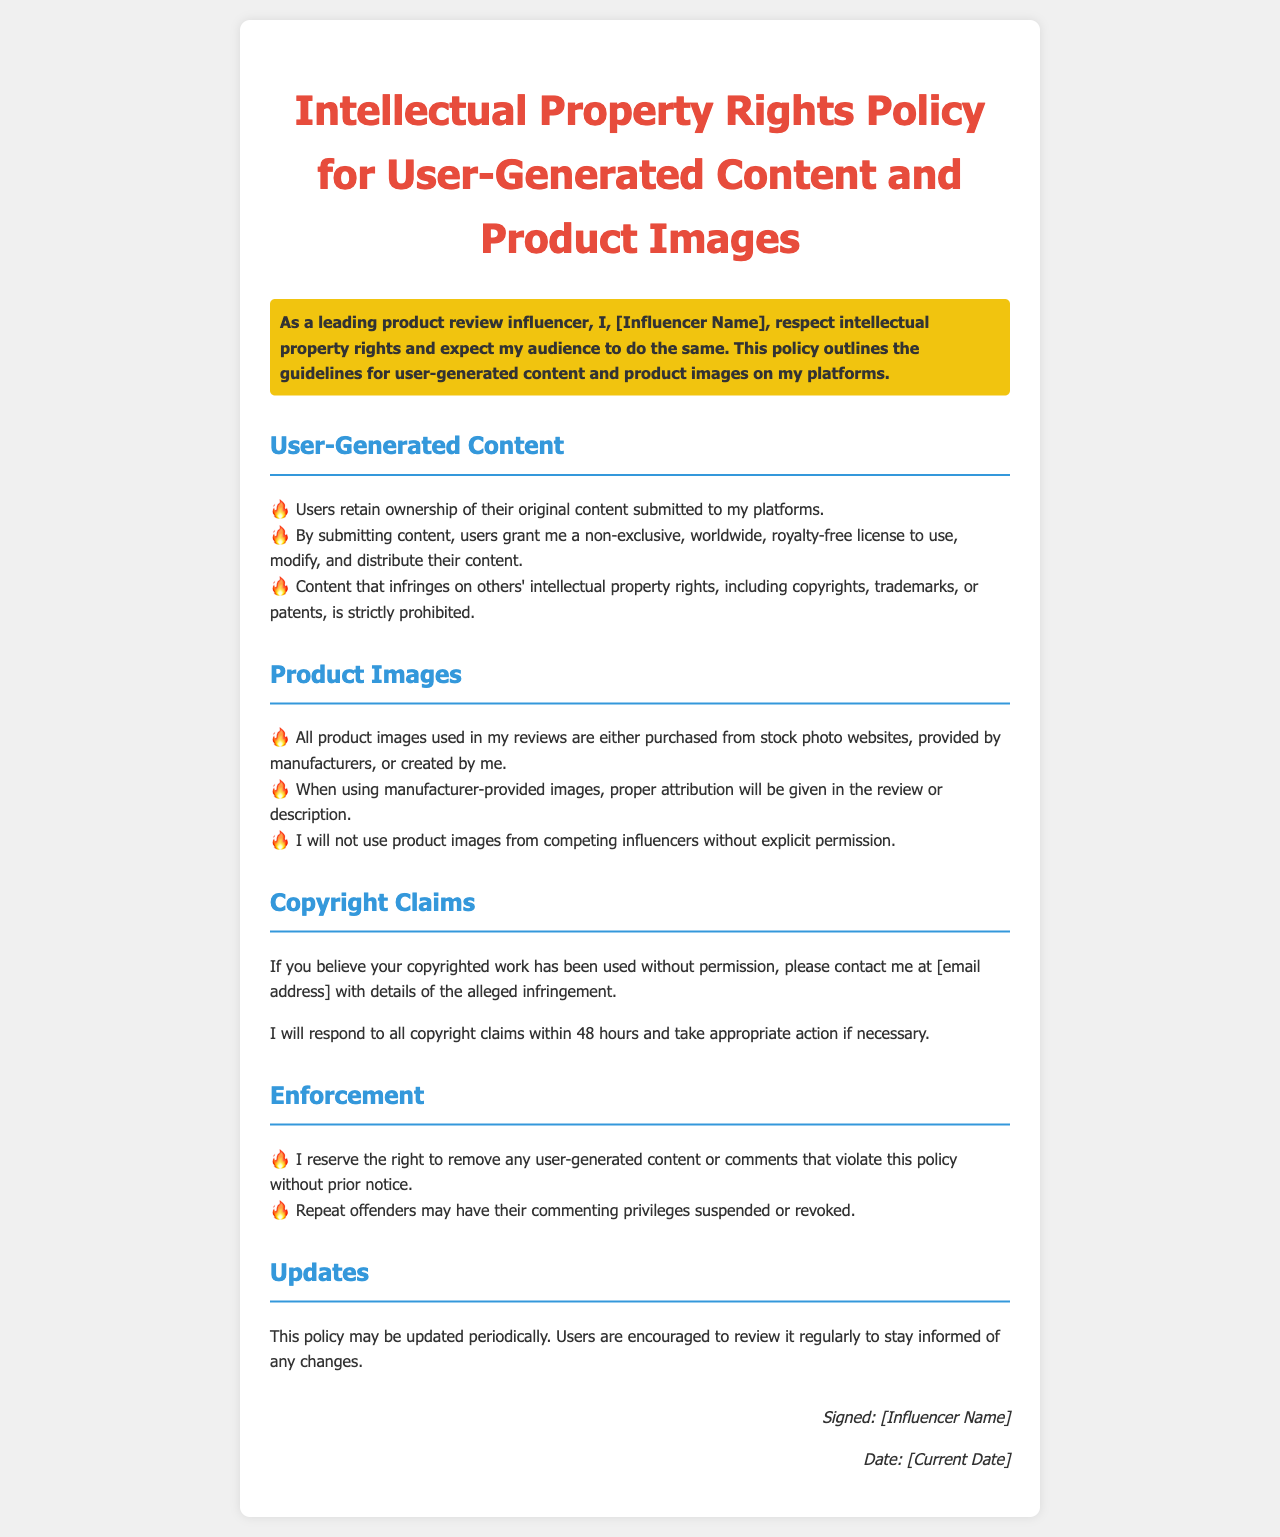What is the title of the document? The title is stated at the top of the document as "Intellectual Property Rights Policy for User-Generated Content and Product Images."
Answer: Intellectual Property Rights Policy for User-Generated Content and Product Images Who retains ownership of user-generated content? The document specifies that users retain ownership of their original content submitted to the platforms.
Answer: Users What type of license do users grant upon content submission? Users grant a non-exclusive, worldwide, royalty-free license to use, modify, and distribute their content, as detailed in the policy.
Answer: Non-exclusive, worldwide, royalty-free license What should users do if they believe their copyrighted work is used without permission? The policy instructs users to contact the influencer via email with details of the alleged infringement.
Answer: Contact via email How long will it take for the influencer to respond to copyright claims? The document mentions a response time of 48 hours for copyright claims.
Answer: 48 hours What actions can be taken against repeat offenders? The policy states that repeat offenders may have their commenting privileges suspended or revoked.
Answer: Suspension or revocation of commenting privileges What is the main purpose of this policy document? The main purpose is to outline guidelines for user-generated content and product images in relation to intellectual property rights.
Answer: Guidelines for user-generated content and product images Are users encouraged to review the policy regularly? Yes, the policy includes a statement encouraging users to review it regularly for updates.
Answer: Yes What type of images will not be used without permission? The document specifies that product images from competing influencers will not be used without explicit permission.
Answer: Competing influencers’ product images 